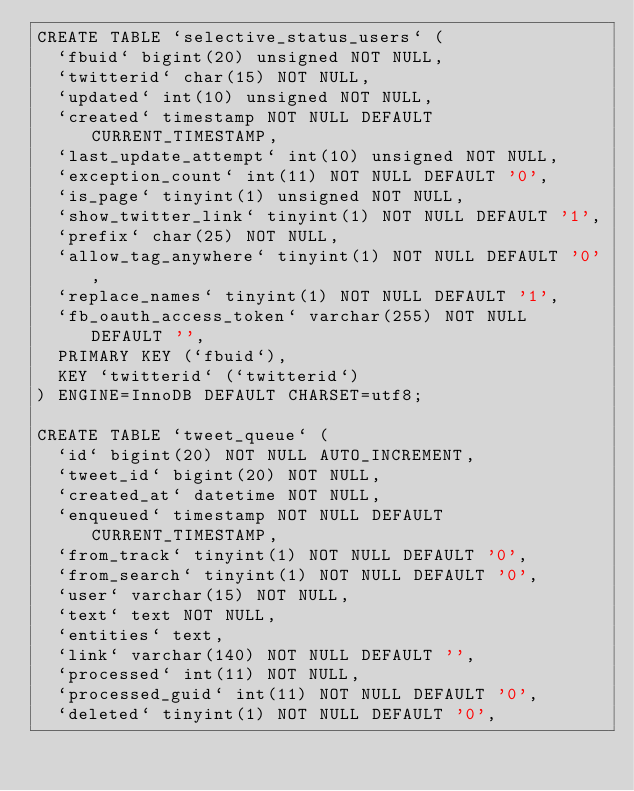<code> <loc_0><loc_0><loc_500><loc_500><_SQL_>CREATE TABLE `selective_status_users` (
  `fbuid` bigint(20) unsigned NOT NULL,
  `twitterid` char(15) NOT NULL,
  `updated` int(10) unsigned NOT NULL,
  `created` timestamp NOT NULL DEFAULT CURRENT_TIMESTAMP,
  `last_update_attempt` int(10) unsigned NOT NULL,
  `exception_count` int(11) NOT NULL DEFAULT '0',
  `is_page` tinyint(1) unsigned NOT NULL,
  `show_twitter_link` tinyint(1) NOT NULL DEFAULT '1',
  `prefix` char(25) NOT NULL,
  `allow_tag_anywhere` tinyint(1) NOT NULL DEFAULT '0',
  `replace_names` tinyint(1) NOT NULL DEFAULT '1',
  `fb_oauth_access_token` varchar(255) NOT NULL DEFAULT '',
  PRIMARY KEY (`fbuid`),
  KEY `twitterid` (`twitterid`)
) ENGINE=InnoDB DEFAULT CHARSET=utf8;

CREATE TABLE `tweet_queue` (
  `id` bigint(20) NOT NULL AUTO_INCREMENT,
  `tweet_id` bigint(20) NOT NULL,
  `created_at` datetime NOT NULL,
  `enqueued` timestamp NOT NULL DEFAULT CURRENT_TIMESTAMP,
  `from_track` tinyint(1) NOT NULL DEFAULT '0',
  `from_search` tinyint(1) NOT NULL DEFAULT '0',
  `user` varchar(15) NOT NULL,
  `text` text NOT NULL,
  `entities` text,
  `link` varchar(140) NOT NULL DEFAULT '',
  `processed` int(11) NOT NULL,
  `processed_guid` int(11) NOT NULL DEFAULT '0',
  `deleted` tinyint(1) NOT NULL DEFAULT '0',</code> 